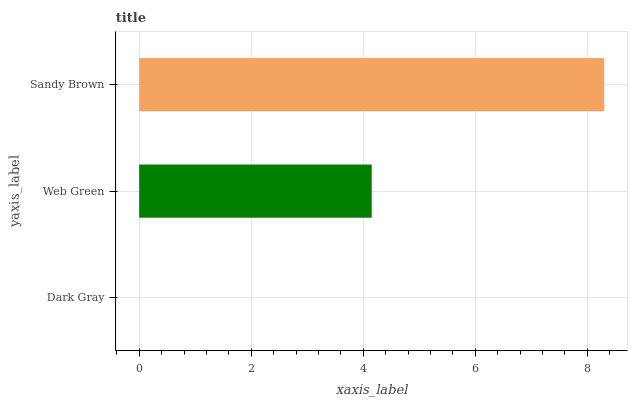Is Dark Gray the minimum?
Answer yes or no. Yes. Is Sandy Brown the maximum?
Answer yes or no. Yes. Is Web Green the minimum?
Answer yes or no. No. Is Web Green the maximum?
Answer yes or no. No. Is Web Green greater than Dark Gray?
Answer yes or no. Yes. Is Dark Gray less than Web Green?
Answer yes or no. Yes. Is Dark Gray greater than Web Green?
Answer yes or no. No. Is Web Green less than Dark Gray?
Answer yes or no. No. Is Web Green the high median?
Answer yes or no. Yes. Is Web Green the low median?
Answer yes or no. Yes. Is Sandy Brown the high median?
Answer yes or no. No. Is Dark Gray the low median?
Answer yes or no. No. 